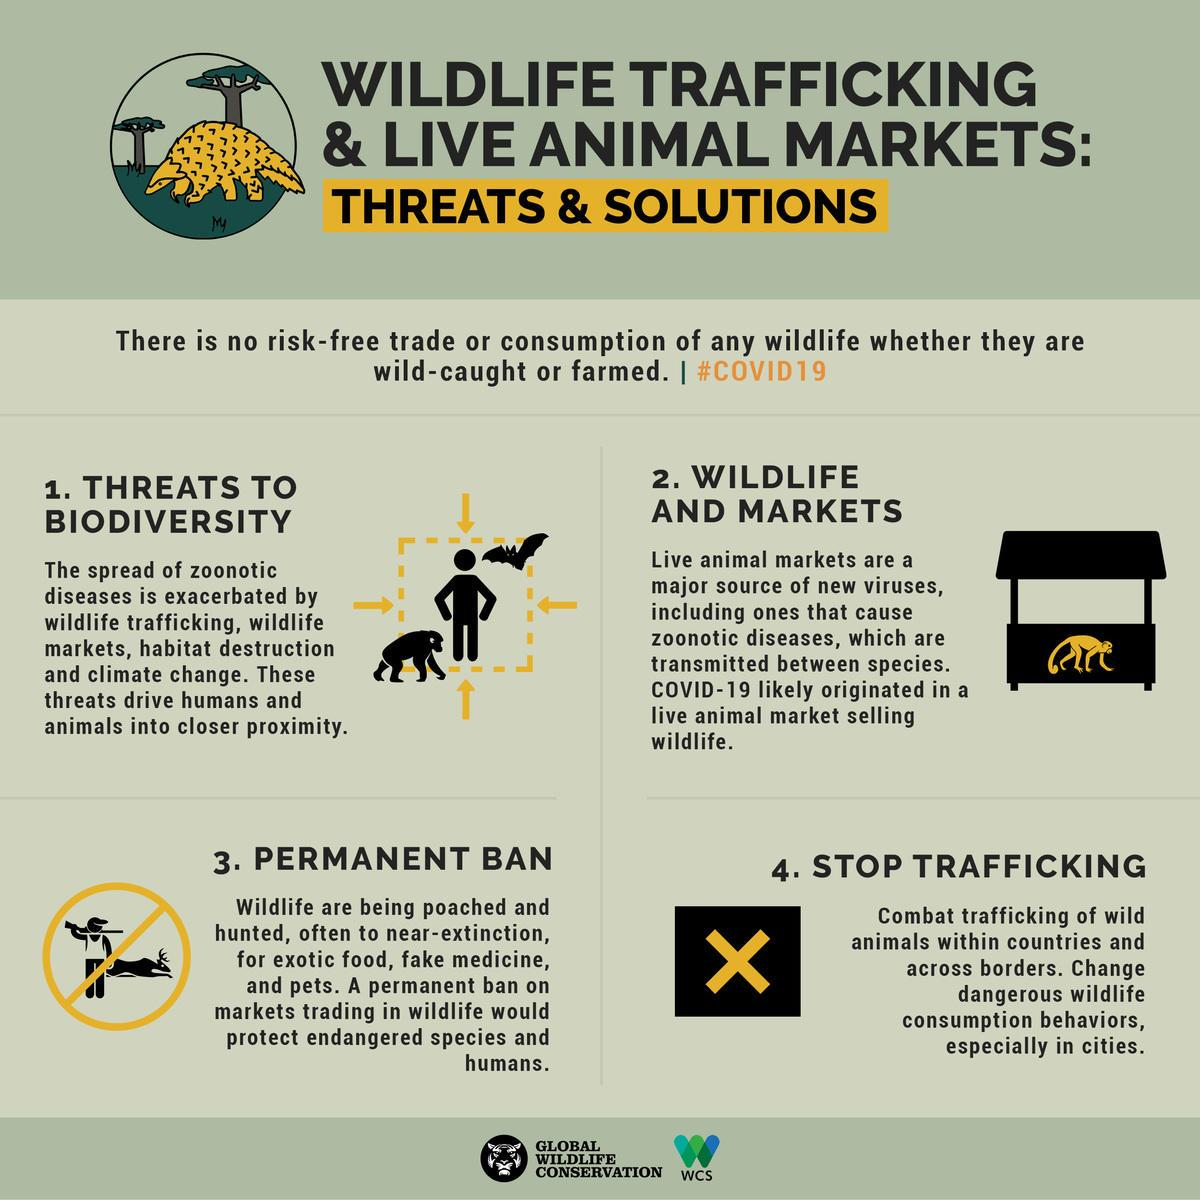Point out several critical features in this image. Zoonotic diseases are communicable conditions that can be transmitted between different species, including humans. 